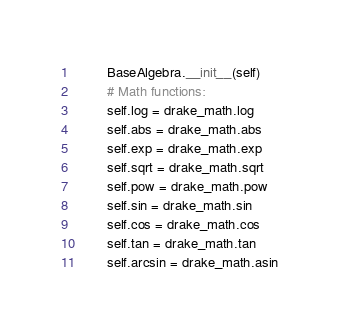<code> <loc_0><loc_0><loc_500><loc_500><_Python_>        BaseAlgebra.__init__(self)
        # Math functions:
        self.log = drake_math.log
        self.abs = drake_math.abs
        self.exp = drake_math.exp
        self.sqrt = drake_math.sqrt
        self.pow = drake_math.pow
        self.sin = drake_math.sin
        self.cos = drake_math.cos
        self.tan = drake_math.tan
        self.arcsin = drake_math.asin</code> 